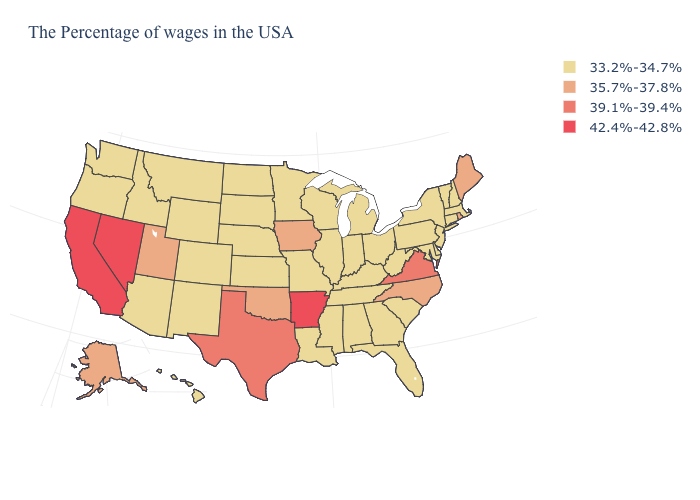Name the states that have a value in the range 39.1%-39.4%?
Be succinct. Virginia, Texas. What is the value of Montana?
Short answer required. 33.2%-34.7%. What is the value of Kentucky?
Be succinct. 33.2%-34.7%. What is the lowest value in the USA?
Give a very brief answer. 33.2%-34.7%. Name the states that have a value in the range 33.2%-34.7%?
Short answer required. Massachusetts, New Hampshire, Vermont, Connecticut, New York, New Jersey, Delaware, Maryland, Pennsylvania, South Carolina, West Virginia, Ohio, Florida, Georgia, Michigan, Kentucky, Indiana, Alabama, Tennessee, Wisconsin, Illinois, Mississippi, Louisiana, Missouri, Minnesota, Kansas, Nebraska, South Dakota, North Dakota, Wyoming, Colorado, New Mexico, Montana, Arizona, Idaho, Washington, Oregon, Hawaii. Name the states that have a value in the range 33.2%-34.7%?
Short answer required. Massachusetts, New Hampshire, Vermont, Connecticut, New York, New Jersey, Delaware, Maryland, Pennsylvania, South Carolina, West Virginia, Ohio, Florida, Georgia, Michigan, Kentucky, Indiana, Alabama, Tennessee, Wisconsin, Illinois, Mississippi, Louisiana, Missouri, Minnesota, Kansas, Nebraska, South Dakota, North Dakota, Wyoming, Colorado, New Mexico, Montana, Arizona, Idaho, Washington, Oregon, Hawaii. What is the lowest value in the MidWest?
Be succinct. 33.2%-34.7%. Name the states that have a value in the range 35.7%-37.8%?
Keep it brief. Maine, Rhode Island, North Carolina, Iowa, Oklahoma, Utah, Alaska. How many symbols are there in the legend?
Concise answer only. 4. Among the states that border Wyoming , does Utah have the lowest value?
Write a very short answer. No. Does Delaware have the lowest value in the South?
Keep it brief. Yes. What is the lowest value in the MidWest?
Concise answer only. 33.2%-34.7%. Which states have the lowest value in the USA?
Answer briefly. Massachusetts, New Hampshire, Vermont, Connecticut, New York, New Jersey, Delaware, Maryland, Pennsylvania, South Carolina, West Virginia, Ohio, Florida, Georgia, Michigan, Kentucky, Indiana, Alabama, Tennessee, Wisconsin, Illinois, Mississippi, Louisiana, Missouri, Minnesota, Kansas, Nebraska, South Dakota, North Dakota, Wyoming, Colorado, New Mexico, Montana, Arizona, Idaho, Washington, Oregon, Hawaii. Which states hav the highest value in the West?
Be succinct. Nevada, California. What is the lowest value in the Northeast?
Answer briefly. 33.2%-34.7%. 